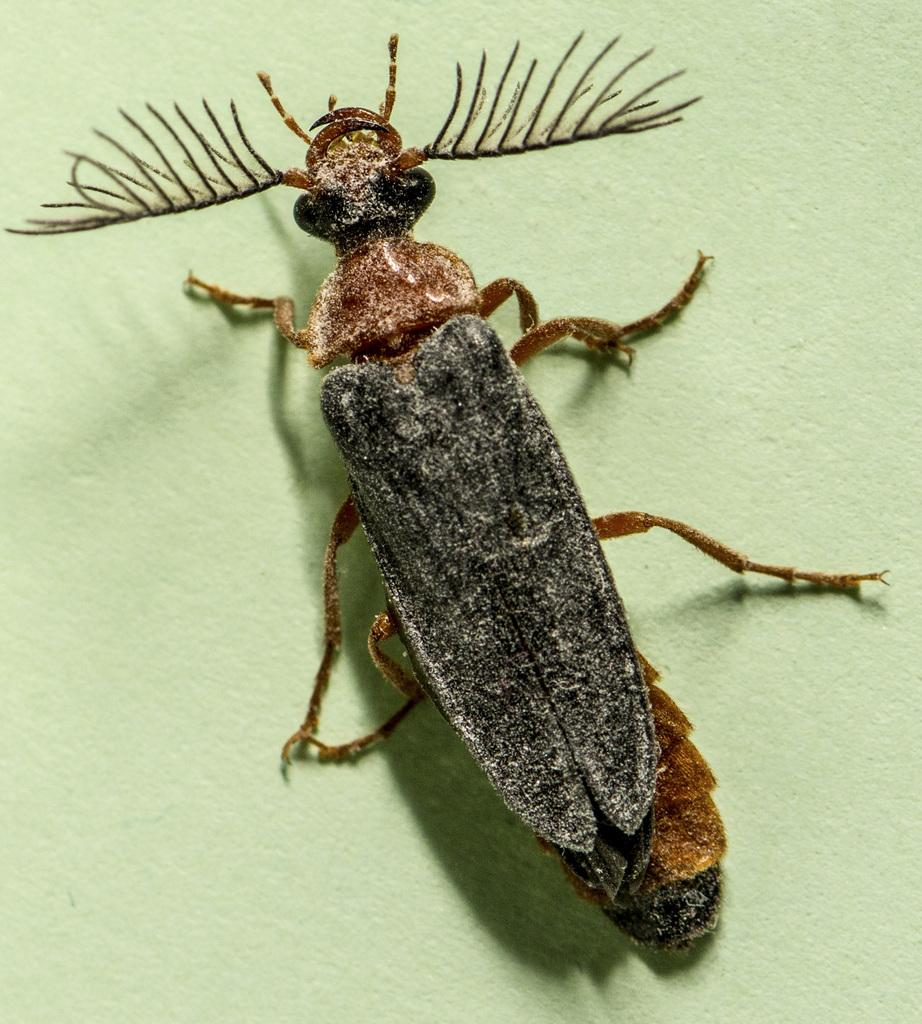What is the main subject of the image? There is an insect in the middle of the image. What type of poison is the girl holding in the image? There is no girl or poison present in the image; it features an insect. 